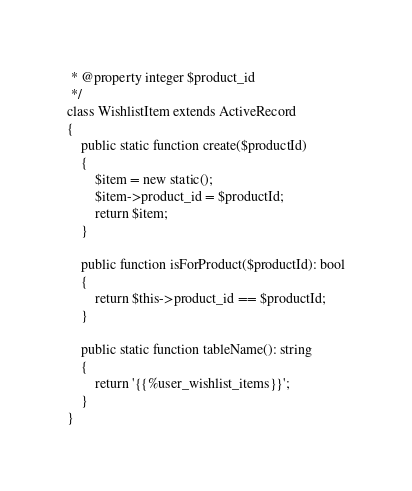<code> <loc_0><loc_0><loc_500><loc_500><_PHP_> * @property integer $product_id
 */
class WishlistItem extends ActiveRecord
{
    public static function create($productId)
    {
        $item = new static();
        $item->product_id = $productId;
        return $item;
    }

    public function isForProduct($productId): bool
    {
        return $this->product_id == $productId;
    }

    public static function tableName(): string
    {
        return '{{%user_wishlist_items}}';
    }
}</code> 